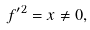Convert formula to latex. <formula><loc_0><loc_0><loc_500><loc_500>f ^ { \prime 2 } = x \neq 0 ,</formula> 